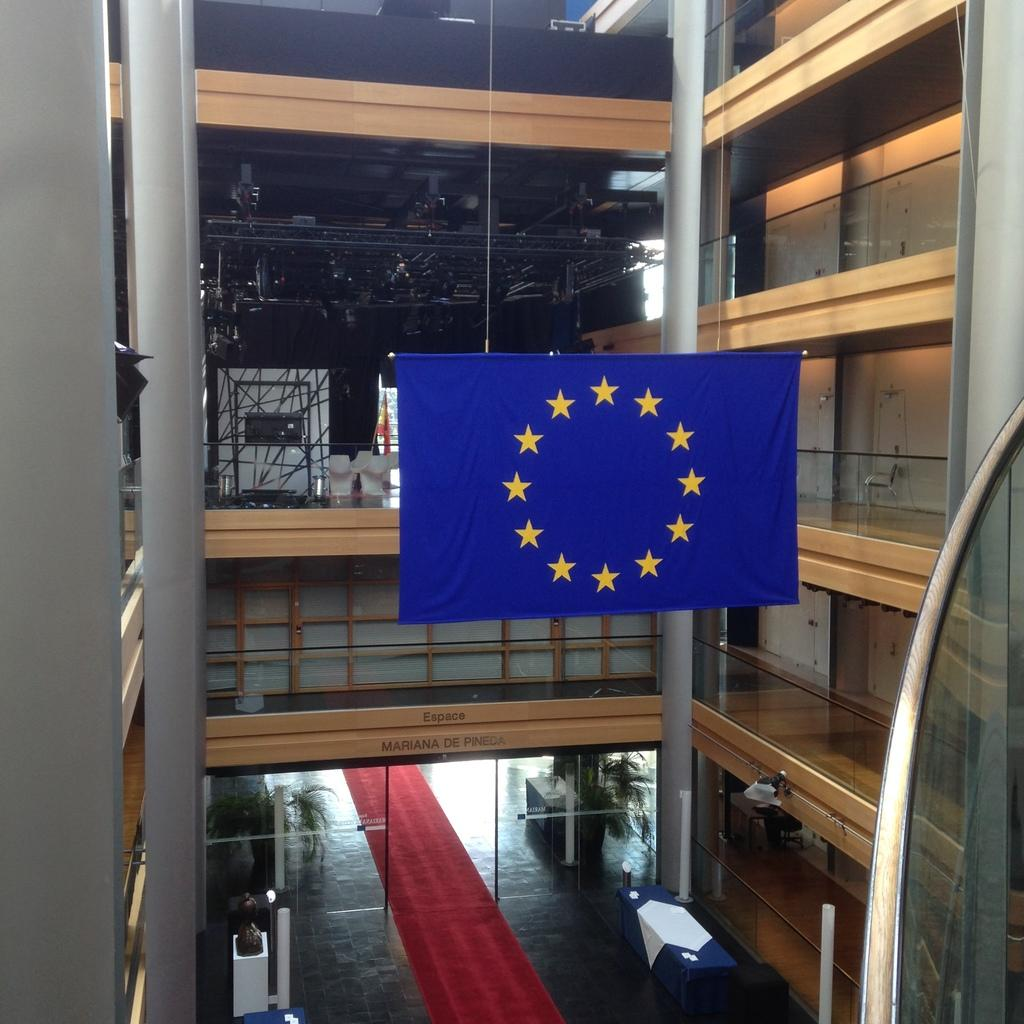What type of establishment is depicted in the image? The building is a five-star hotel. How many floors does the hotel have? The hotel has multiple floors. Are there any amenities or services within the hotel? Yes, there is a restaurant inside the hotel. What can be seen hanging down in the hotel? A flag is hanging down in the hotel. What type of flooring is present in the image? There is a red carpet on the floor. What is the reaction of the nerve in the image? There is no mention of a nerve in the image, so it is not possible to determine its reaction. 